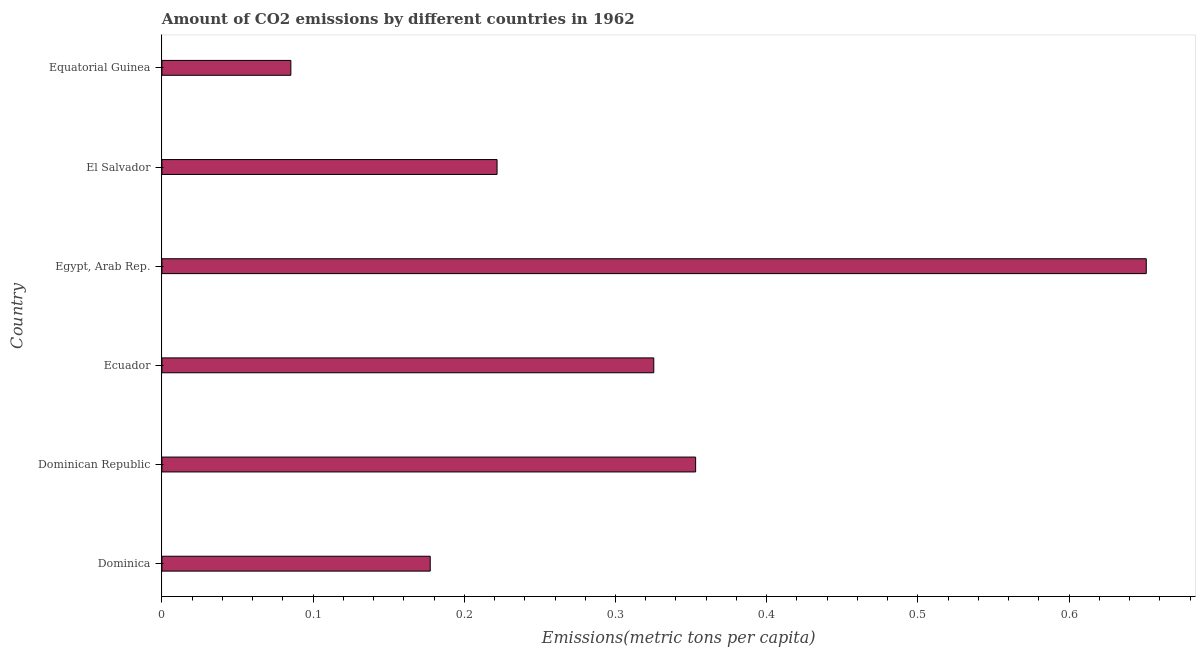What is the title of the graph?
Make the answer very short. Amount of CO2 emissions by different countries in 1962. What is the label or title of the X-axis?
Your answer should be compact. Emissions(metric tons per capita). What is the label or title of the Y-axis?
Make the answer very short. Country. What is the amount of co2 emissions in El Salvador?
Your answer should be compact. 0.22. Across all countries, what is the maximum amount of co2 emissions?
Your response must be concise. 0.65. Across all countries, what is the minimum amount of co2 emissions?
Your answer should be compact. 0.09. In which country was the amount of co2 emissions maximum?
Keep it short and to the point. Egypt, Arab Rep. In which country was the amount of co2 emissions minimum?
Give a very brief answer. Equatorial Guinea. What is the sum of the amount of co2 emissions?
Keep it short and to the point. 1.81. What is the difference between the amount of co2 emissions in Dominican Republic and Egypt, Arab Rep.?
Your answer should be very brief. -0.3. What is the average amount of co2 emissions per country?
Offer a very short reply. 0.3. What is the median amount of co2 emissions?
Offer a very short reply. 0.27. What is the ratio of the amount of co2 emissions in Dominica to that in Dominican Republic?
Keep it short and to the point. 0.5. Is the amount of co2 emissions in Dominican Republic less than that in Egypt, Arab Rep.?
Your response must be concise. Yes. Is the difference between the amount of co2 emissions in Dominica and Equatorial Guinea greater than the difference between any two countries?
Provide a succinct answer. No. What is the difference between the highest and the second highest amount of co2 emissions?
Your answer should be very brief. 0.3. What is the difference between the highest and the lowest amount of co2 emissions?
Offer a very short reply. 0.57. How many bars are there?
Ensure brevity in your answer.  6. Are all the bars in the graph horizontal?
Your response must be concise. Yes. How many countries are there in the graph?
Your answer should be very brief. 6. What is the difference between two consecutive major ticks on the X-axis?
Provide a short and direct response. 0.1. Are the values on the major ticks of X-axis written in scientific E-notation?
Ensure brevity in your answer.  No. What is the Emissions(metric tons per capita) of Dominica?
Offer a terse response. 0.18. What is the Emissions(metric tons per capita) in Dominican Republic?
Keep it short and to the point. 0.35. What is the Emissions(metric tons per capita) of Ecuador?
Offer a terse response. 0.33. What is the Emissions(metric tons per capita) of Egypt, Arab Rep.?
Keep it short and to the point. 0.65. What is the Emissions(metric tons per capita) in El Salvador?
Your answer should be very brief. 0.22. What is the Emissions(metric tons per capita) of Equatorial Guinea?
Provide a short and direct response. 0.09. What is the difference between the Emissions(metric tons per capita) in Dominica and Dominican Republic?
Keep it short and to the point. -0.18. What is the difference between the Emissions(metric tons per capita) in Dominica and Ecuador?
Your answer should be compact. -0.15. What is the difference between the Emissions(metric tons per capita) in Dominica and Egypt, Arab Rep.?
Provide a succinct answer. -0.47. What is the difference between the Emissions(metric tons per capita) in Dominica and El Salvador?
Keep it short and to the point. -0.04. What is the difference between the Emissions(metric tons per capita) in Dominica and Equatorial Guinea?
Offer a very short reply. 0.09. What is the difference between the Emissions(metric tons per capita) in Dominican Republic and Ecuador?
Your answer should be very brief. 0.03. What is the difference between the Emissions(metric tons per capita) in Dominican Republic and Egypt, Arab Rep.?
Provide a succinct answer. -0.3. What is the difference between the Emissions(metric tons per capita) in Dominican Republic and El Salvador?
Offer a terse response. 0.13. What is the difference between the Emissions(metric tons per capita) in Dominican Republic and Equatorial Guinea?
Provide a short and direct response. 0.27. What is the difference between the Emissions(metric tons per capita) in Ecuador and Egypt, Arab Rep.?
Make the answer very short. -0.33. What is the difference between the Emissions(metric tons per capita) in Ecuador and El Salvador?
Ensure brevity in your answer.  0.1. What is the difference between the Emissions(metric tons per capita) in Ecuador and Equatorial Guinea?
Offer a very short reply. 0.24. What is the difference between the Emissions(metric tons per capita) in Egypt, Arab Rep. and El Salvador?
Your response must be concise. 0.43. What is the difference between the Emissions(metric tons per capita) in Egypt, Arab Rep. and Equatorial Guinea?
Provide a short and direct response. 0.57. What is the difference between the Emissions(metric tons per capita) in El Salvador and Equatorial Guinea?
Give a very brief answer. 0.14. What is the ratio of the Emissions(metric tons per capita) in Dominica to that in Dominican Republic?
Provide a succinct answer. 0.5. What is the ratio of the Emissions(metric tons per capita) in Dominica to that in Ecuador?
Make the answer very short. 0.55. What is the ratio of the Emissions(metric tons per capita) in Dominica to that in Egypt, Arab Rep.?
Offer a terse response. 0.27. What is the ratio of the Emissions(metric tons per capita) in Dominica to that in El Salvador?
Give a very brief answer. 0.8. What is the ratio of the Emissions(metric tons per capita) in Dominica to that in Equatorial Guinea?
Give a very brief answer. 2.08. What is the ratio of the Emissions(metric tons per capita) in Dominican Republic to that in Ecuador?
Give a very brief answer. 1.08. What is the ratio of the Emissions(metric tons per capita) in Dominican Republic to that in Egypt, Arab Rep.?
Your response must be concise. 0.54. What is the ratio of the Emissions(metric tons per capita) in Dominican Republic to that in El Salvador?
Your response must be concise. 1.59. What is the ratio of the Emissions(metric tons per capita) in Dominican Republic to that in Equatorial Guinea?
Make the answer very short. 4.14. What is the ratio of the Emissions(metric tons per capita) in Ecuador to that in Egypt, Arab Rep.?
Make the answer very short. 0.5. What is the ratio of the Emissions(metric tons per capita) in Ecuador to that in El Salvador?
Offer a very short reply. 1.47. What is the ratio of the Emissions(metric tons per capita) in Ecuador to that in Equatorial Guinea?
Offer a very short reply. 3.81. What is the ratio of the Emissions(metric tons per capita) in Egypt, Arab Rep. to that in El Salvador?
Your answer should be very brief. 2.94. What is the ratio of the Emissions(metric tons per capita) in Egypt, Arab Rep. to that in Equatorial Guinea?
Ensure brevity in your answer.  7.63. What is the ratio of the Emissions(metric tons per capita) in El Salvador to that in Equatorial Guinea?
Your answer should be compact. 2.6. 